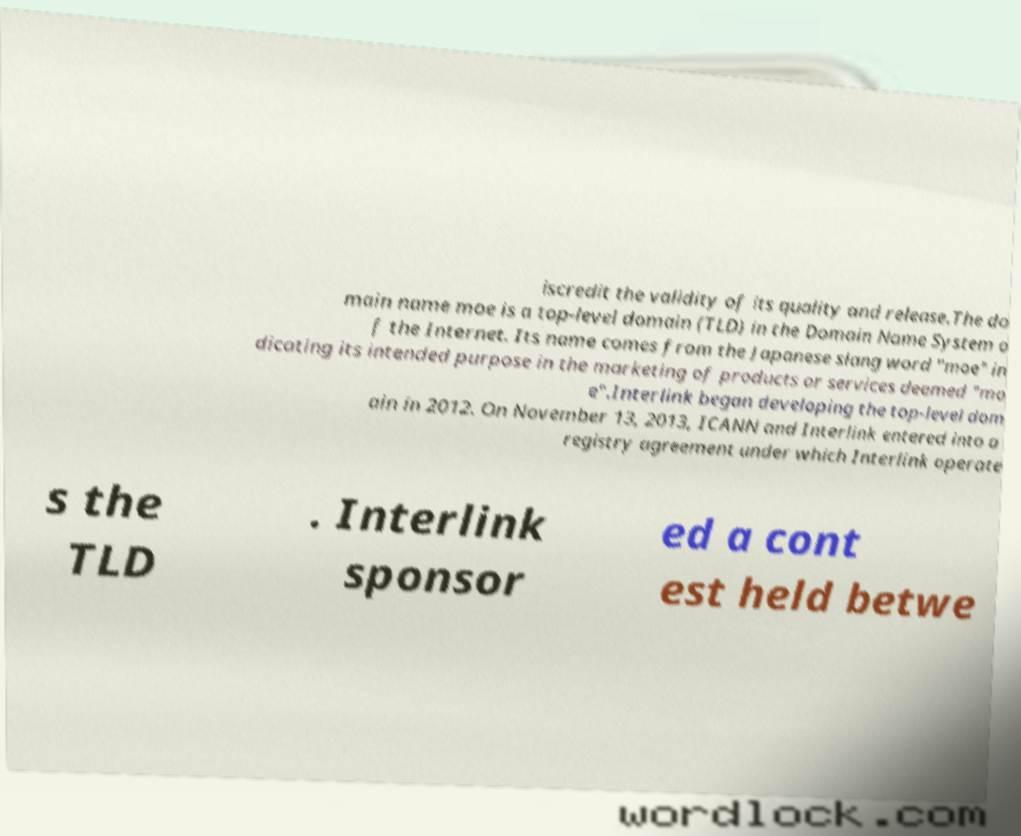For documentation purposes, I need the text within this image transcribed. Could you provide that? iscredit the validity of its quality and release.The do main name moe is a top-level domain (TLD) in the Domain Name System o f the Internet. Its name comes from the Japanese slang word "moe" in dicating its intended purpose in the marketing of products or services deemed "mo e".Interlink began developing the top-level dom ain in 2012. On November 13, 2013, ICANN and Interlink entered into a registry agreement under which Interlink operate s the TLD . Interlink sponsor ed a cont est held betwe 